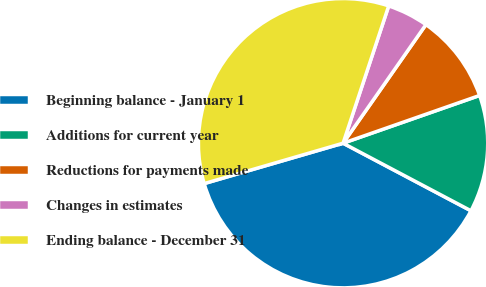Convert chart. <chart><loc_0><loc_0><loc_500><loc_500><pie_chart><fcel>Beginning balance - January 1<fcel>Additions for current year<fcel>Reductions for payments made<fcel>Changes in estimates<fcel>Ending balance - December 31<nl><fcel>37.76%<fcel>13.09%<fcel>9.94%<fcel>4.6%<fcel>34.61%<nl></chart> 